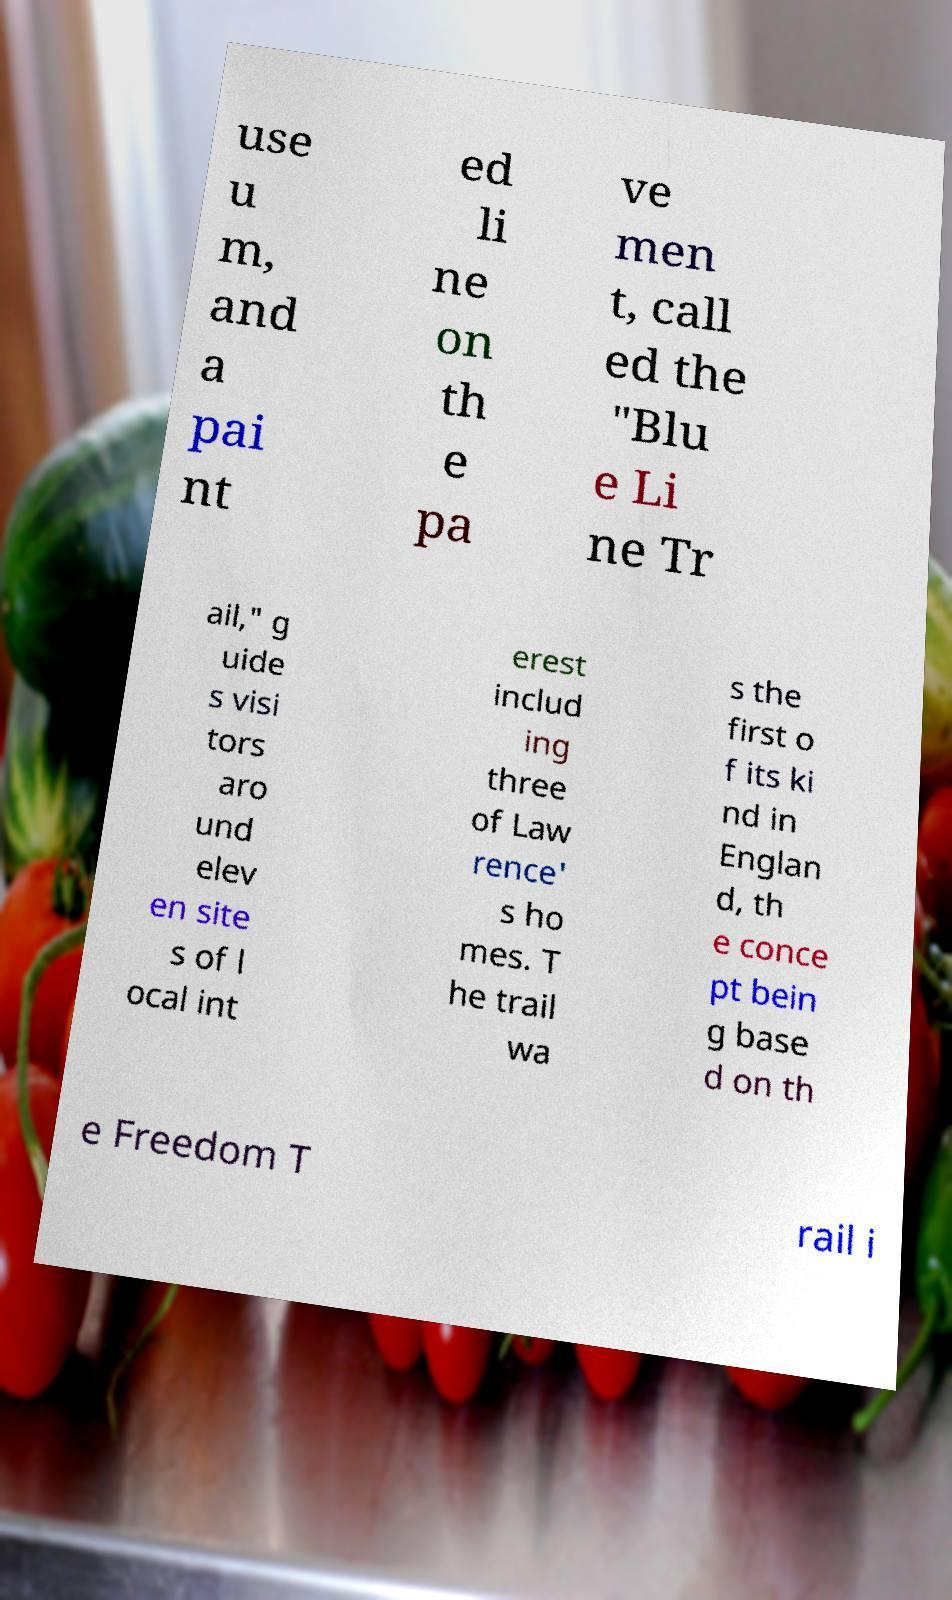Please identify and transcribe the text found in this image. use u m, and a pai nt ed li ne on th e pa ve men t, call ed the "Blu e Li ne Tr ail," g uide s visi tors aro und elev en site s of l ocal int erest includ ing three of Law rence' s ho mes. T he trail wa s the first o f its ki nd in Englan d, th e conce pt bein g base d on th e Freedom T rail i 